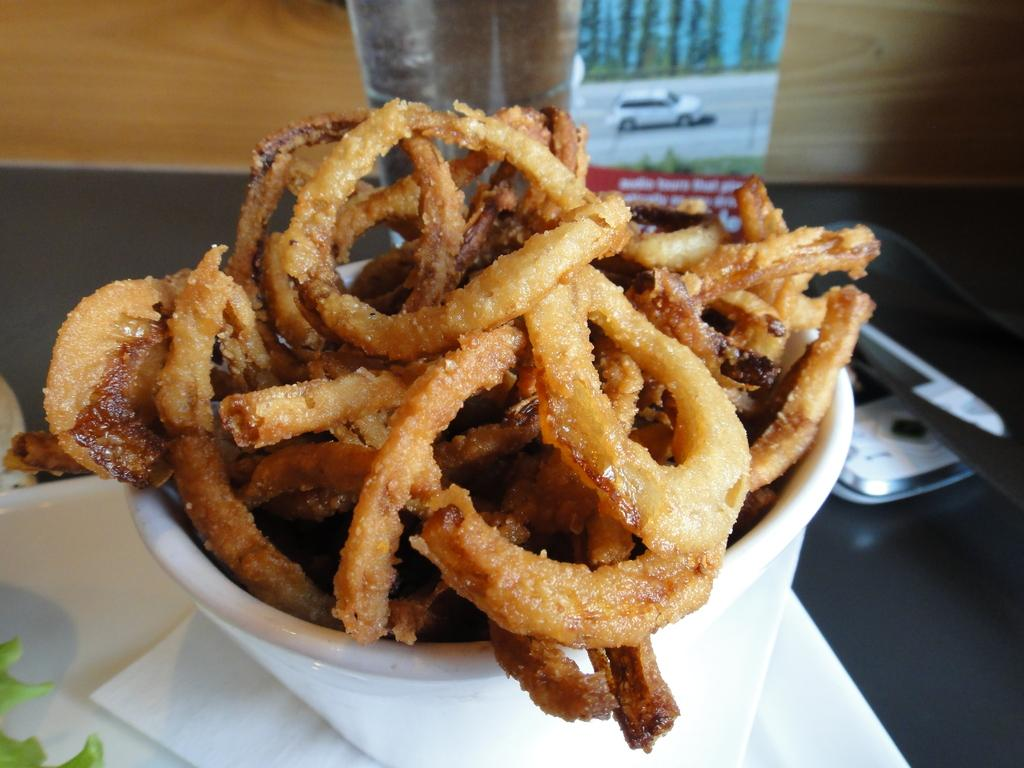What can be seen on the table in the image? There are different types of food and objects on the table in the image. What is depicted on the poster in the image? The poster contains images of trees, grass, and a car on the road. How many different types of images are on the poster? There are three different types of images on the poster: trees, grass, and a car on the road. What type of popcorn is being served in the yard in the image? There is no popcorn or yard present in the image. What type of vessel is used to serve the food in the image? The provided facts do not mention a vessel being used to serve the food in the image. 